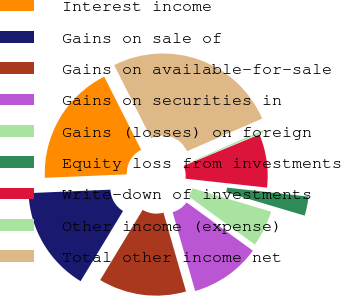Convert chart. <chart><loc_0><loc_0><loc_500><loc_500><pie_chart><fcel>Interest income<fcel>Gains on sale of<fcel>Gains on available-for-sale<fcel>Gains on securities in<fcel>Gains (losses) on foreign<fcel>Equity loss from investments<fcel>Write-down of investments<fcel>Other income (expense)<fcel>Total other income net<nl><fcel>18.23%<fcel>15.67%<fcel>13.1%<fcel>10.54%<fcel>5.42%<fcel>2.86%<fcel>7.98%<fcel>0.29%<fcel>25.91%<nl></chart> 